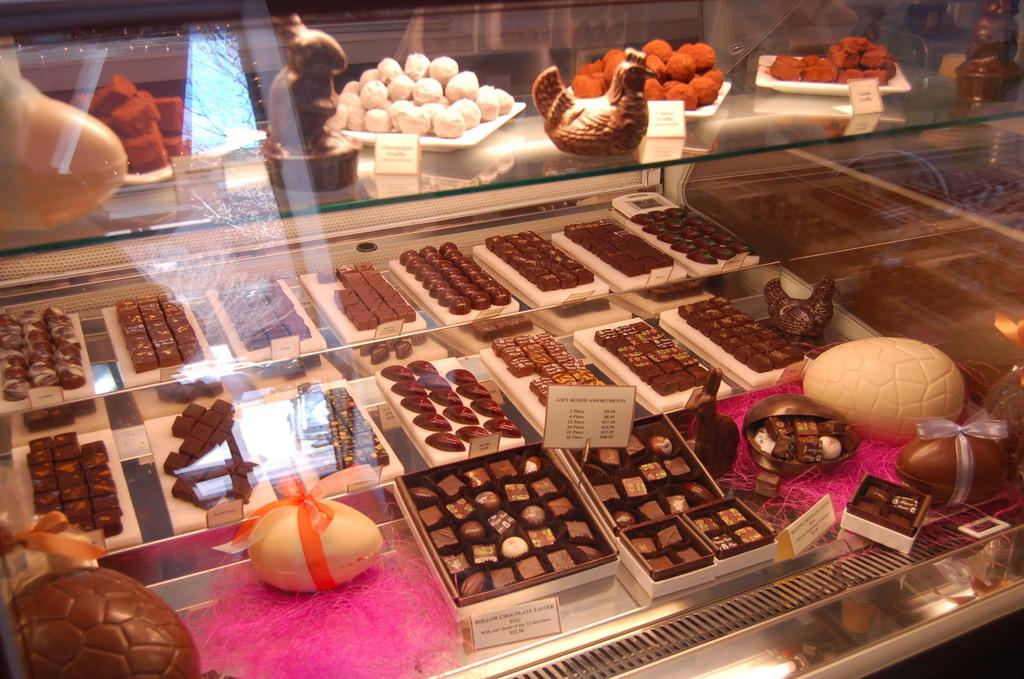What type of food items are present in the image? There are chocolates and sweets in the image. How are the chocolates and sweets packaged? Both chocolates and sweets are in cardboard boxes. Can you see the father holding a camera in the image? There is no mention of a father, camera, or any person in the image. The image only contains chocolates and sweets in cardboard boxes. 